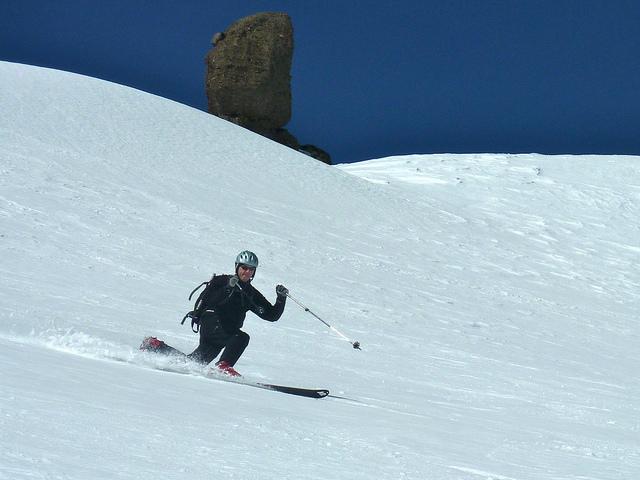Is the person going uphill or downhill?
Quick response, please. Downhill. How fast is the person going?
Quick response, please. Very fast. Is the man moving from left to right or right to left?
Quick response, please. Left to right. What is the guy doing?
Write a very short answer. Skiing. 